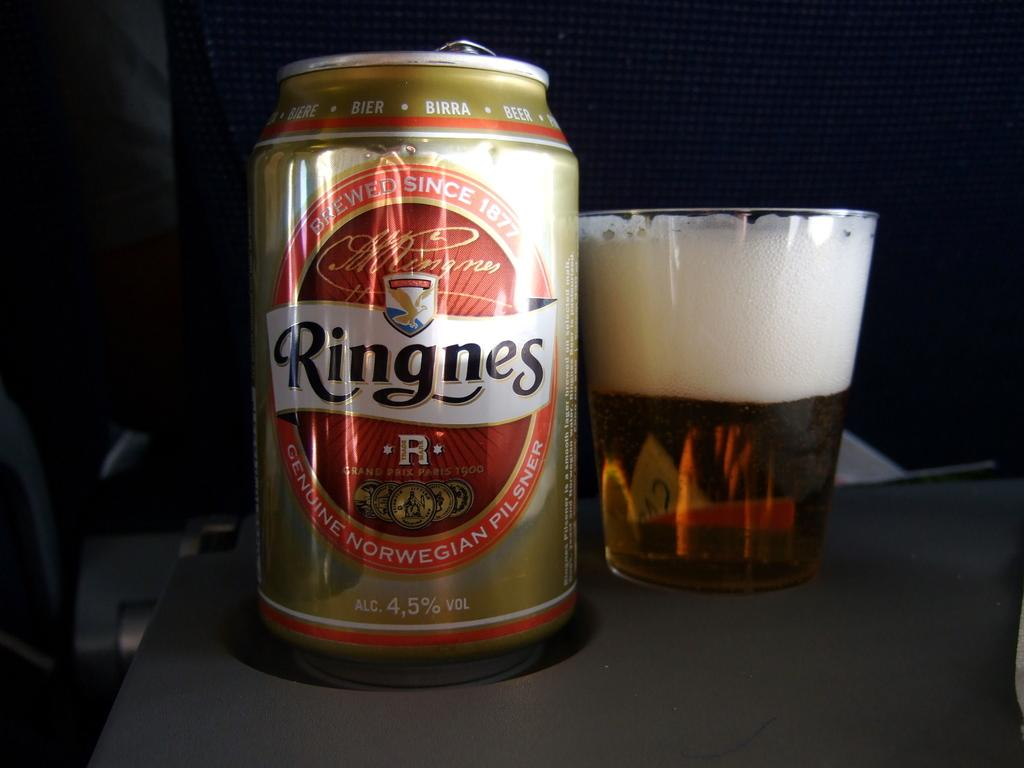Provide a one-sentence caption for the provided image. bottle of beer the brand is ringnes and filled cup. 